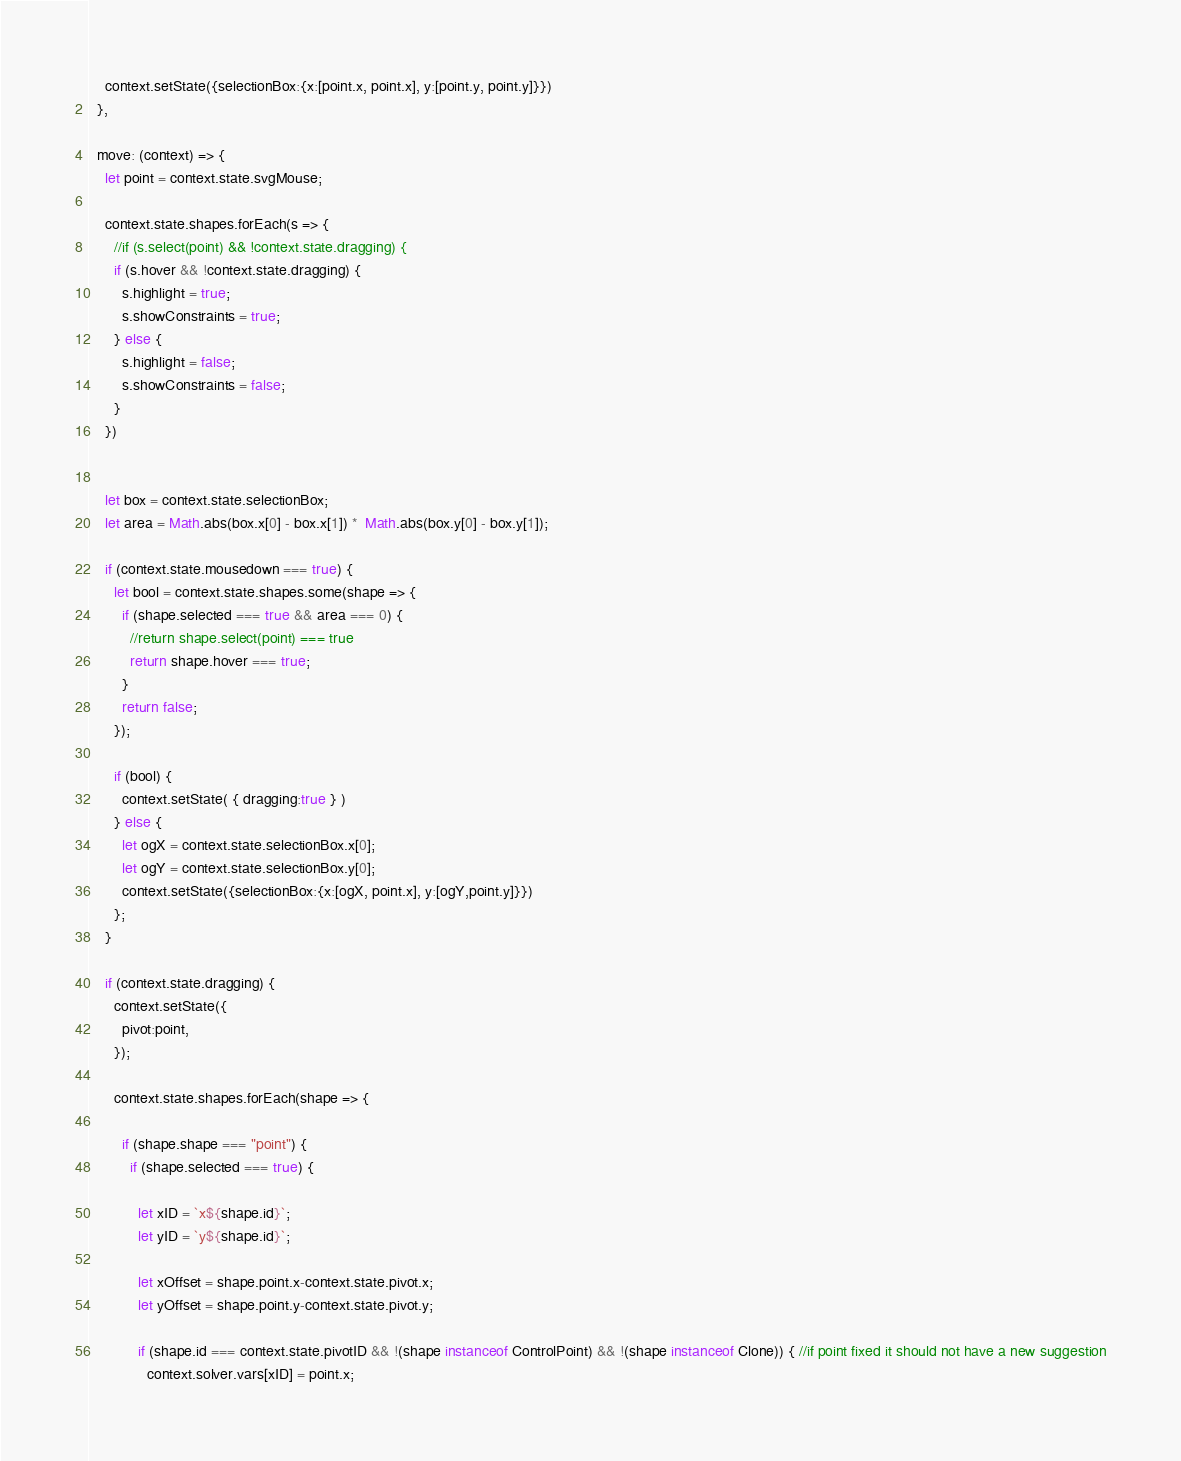Convert code to text. <code><loc_0><loc_0><loc_500><loc_500><_JavaScript_>
    context.setState({selectionBox:{x:[point.x, point.x], y:[point.y, point.y]}})
  },

  move: (context) => {
    let point = context.state.svgMouse;

    context.state.shapes.forEach(s => {
      //if (s.select(point) && !context.state.dragging) {
      if (s.hover && !context.state.dragging) {
        s.highlight = true;
        s.showConstraints = true;
      } else {
        s.highlight = false;
        s.showConstraints = false;
      }
    })


    let box = context.state.selectionBox;
    let area = Math.abs(box.x[0] - box.x[1]) *  Math.abs(box.y[0] - box.y[1]);

    if (context.state.mousedown === true) {
      let bool = context.state.shapes.some(shape => {
        if (shape.selected === true && area === 0) {
          //return shape.select(point) === true
          return shape.hover === true;
        }
        return false;
      });

      if (bool) {
        context.setState( { dragging:true } )
      } else {
        let ogX = context.state.selectionBox.x[0];
        let ogY = context.state.selectionBox.y[0];
        context.setState({selectionBox:{x:[ogX, point.x], y:[ogY,point.y]}})
      };
    }

    if (context.state.dragging) {
      context.setState({
        pivot:point,
      });

      context.state.shapes.forEach(shape => {

        if (shape.shape === "point") {
          if (shape.selected === true) {

            let xID = `x${shape.id}`;
            let yID = `y${shape.id}`;

            let xOffset = shape.point.x-context.state.pivot.x;
            let yOffset = shape.point.y-context.state.pivot.y;

            if (shape.id === context.state.pivotID && !(shape instanceof ControlPoint) && !(shape instanceof Clone)) { //if point fixed it should not have a new suggestion
              context.solver.vars[xID] = point.x;</code> 